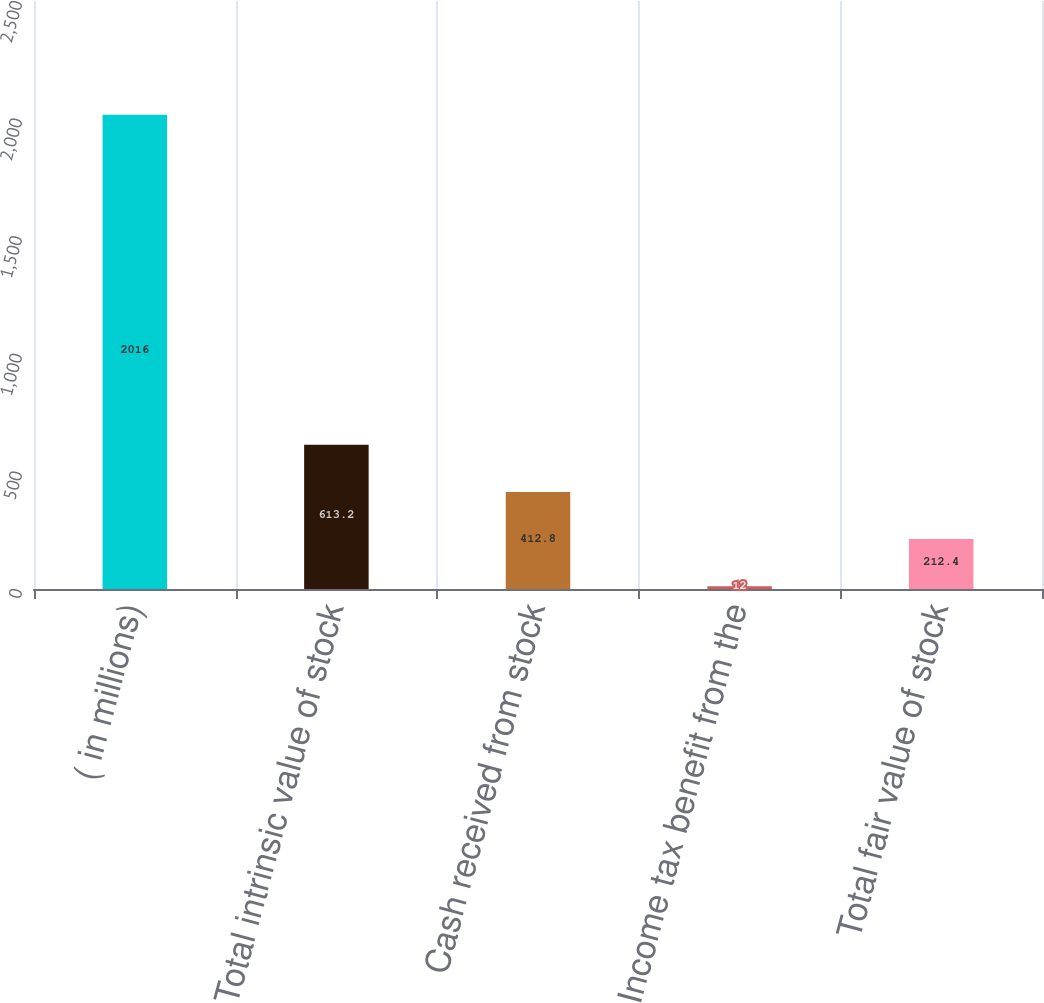Convert chart. <chart><loc_0><loc_0><loc_500><loc_500><bar_chart><fcel>( in millions)<fcel>Total intrinsic value of stock<fcel>Cash received from stock<fcel>Income tax benefit from the<fcel>Total fair value of stock<nl><fcel>2016<fcel>613.2<fcel>412.8<fcel>12<fcel>212.4<nl></chart> 